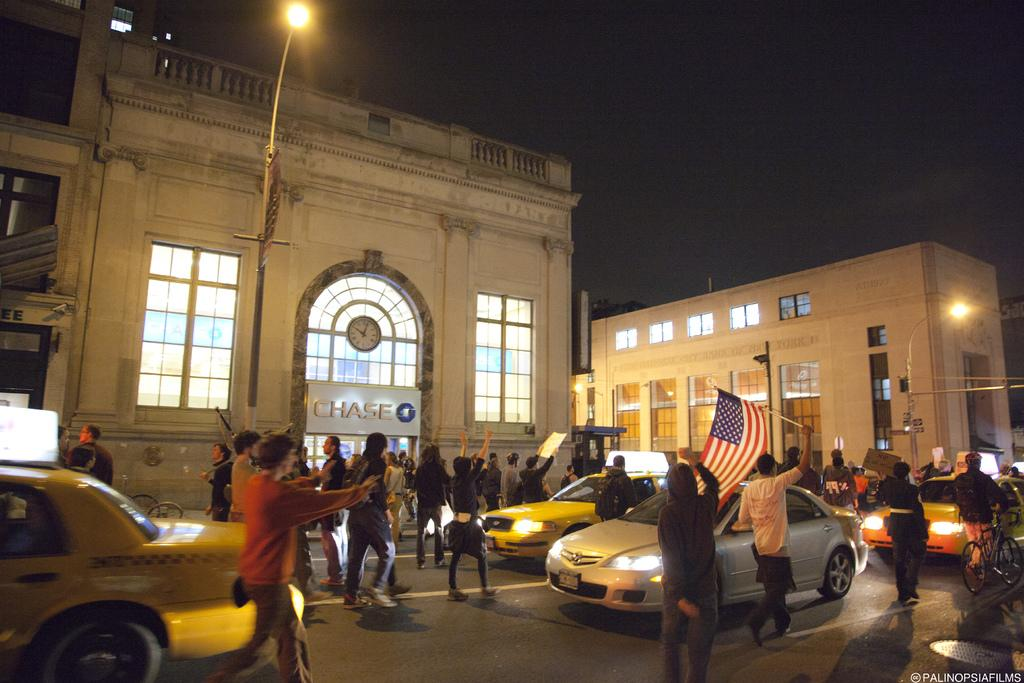Provide a one-sentence caption for the provided image. People gathered halting traffic outside of the Chase bank. 